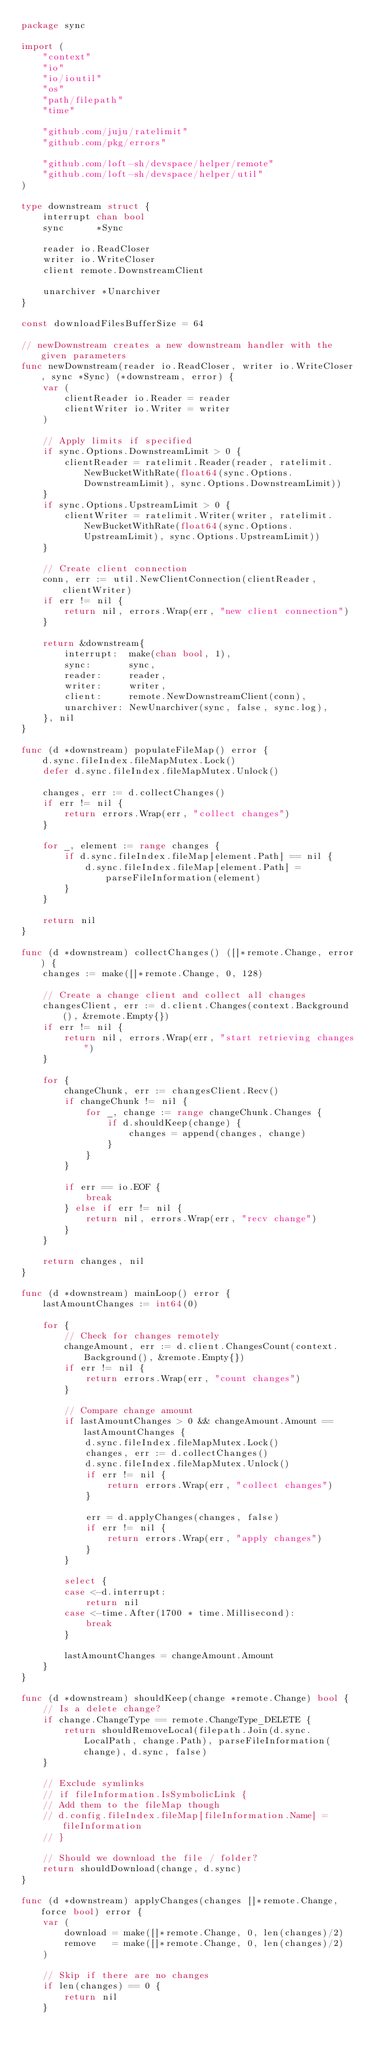Convert code to text. <code><loc_0><loc_0><loc_500><loc_500><_Go_>package sync

import (
	"context"
	"io"
	"io/ioutil"
	"os"
	"path/filepath"
	"time"

	"github.com/juju/ratelimit"
	"github.com/pkg/errors"

	"github.com/loft-sh/devspace/helper/remote"
	"github.com/loft-sh/devspace/helper/util"
)

type downstream struct {
	interrupt chan bool
	sync      *Sync

	reader io.ReadCloser
	writer io.WriteCloser
	client remote.DownstreamClient

	unarchiver *Unarchiver
}

const downloadFilesBufferSize = 64

// newDownstream creates a new downstream handler with the given parameters
func newDownstream(reader io.ReadCloser, writer io.WriteCloser, sync *Sync) (*downstream, error) {
	var (
		clientReader io.Reader = reader
		clientWriter io.Writer = writer
	)

	// Apply limits if specified
	if sync.Options.DownstreamLimit > 0 {
		clientReader = ratelimit.Reader(reader, ratelimit.NewBucketWithRate(float64(sync.Options.DownstreamLimit), sync.Options.DownstreamLimit))
	}
	if sync.Options.UpstreamLimit > 0 {
		clientWriter = ratelimit.Writer(writer, ratelimit.NewBucketWithRate(float64(sync.Options.UpstreamLimit), sync.Options.UpstreamLimit))
	}

	// Create client connection
	conn, err := util.NewClientConnection(clientReader, clientWriter)
	if err != nil {
		return nil, errors.Wrap(err, "new client connection")
	}

	return &downstream{
		interrupt:  make(chan bool, 1),
		sync:       sync,
		reader:     reader,
		writer:     writer,
		client:     remote.NewDownstreamClient(conn),
		unarchiver: NewUnarchiver(sync, false, sync.log),
	}, nil
}

func (d *downstream) populateFileMap() error {
	d.sync.fileIndex.fileMapMutex.Lock()
	defer d.sync.fileIndex.fileMapMutex.Unlock()

	changes, err := d.collectChanges()
	if err != nil {
		return errors.Wrap(err, "collect changes")
	}

	for _, element := range changes {
		if d.sync.fileIndex.fileMap[element.Path] == nil {
			d.sync.fileIndex.fileMap[element.Path] = parseFileInformation(element)
		}
	}

	return nil
}

func (d *downstream) collectChanges() ([]*remote.Change, error) {
	changes := make([]*remote.Change, 0, 128)

	// Create a change client and collect all changes
	changesClient, err := d.client.Changes(context.Background(), &remote.Empty{})
	if err != nil {
		return nil, errors.Wrap(err, "start retrieving changes")
	}

	for {
		changeChunk, err := changesClient.Recv()
		if changeChunk != nil {
			for _, change := range changeChunk.Changes {
				if d.shouldKeep(change) {
					changes = append(changes, change)
				}
			}
		}

		if err == io.EOF {
			break
		} else if err != nil {
			return nil, errors.Wrap(err, "recv change")
		}
	}

	return changes, nil
}

func (d *downstream) mainLoop() error {
	lastAmountChanges := int64(0)

	for {
		// Check for changes remotely
		changeAmount, err := d.client.ChangesCount(context.Background(), &remote.Empty{})
		if err != nil {
			return errors.Wrap(err, "count changes")
		}

		// Compare change amount
		if lastAmountChanges > 0 && changeAmount.Amount == lastAmountChanges {
			d.sync.fileIndex.fileMapMutex.Lock()
			changes, err := d.collectChanges()
			d.sync.fileIndex.fileMapMutex.Unlock()
			if err != nil {
				return errors.Wrap(err, "collect changes")
			}

			err = d.applyChanges(changes, false)
			if err != nil {
				return errors.Wrap(err, "apply changes")
			}
		}

		select {
		case <-d.interrupt:
			return nil
		case <-time.After(1700 * time.Millisecond):
			break
		}

		lastAmountChanges = changeAmount.Amount
	}
}

func (d *downstream) shouldKeep(change *remote.Change) bool {
	// Is a delete change?
	if change.ChangeType == remote.ChangeType_DELETE {
		return shouldRemoveLocal(filepath.Join(d.sync.LocalPath, change.Path), parseFileInformation(change), d.sync, false)
	}

	// Exclude symlinks
	// if fileInformation.IsSymbolicLink {
	// Add them to the fileMap though
	// d.config.fileIndex.fileMap[fileInformation.Name] = fileInformation
	// }

	// Should we download the file / folder?
	return shouldDownload(change, d.sync)
}

func (d *downstream) applyChanges(changes []*remote.Change, force bool) error {
	var (
		download = make([]*remote.Change, 0, len(changes)/2)
		remove   = make([]*remote.Change, 0, len(changes)/2)
	)

	// Skip if there are no changes
	if len(changes) == 0 {
		return nil
	}
</code> 